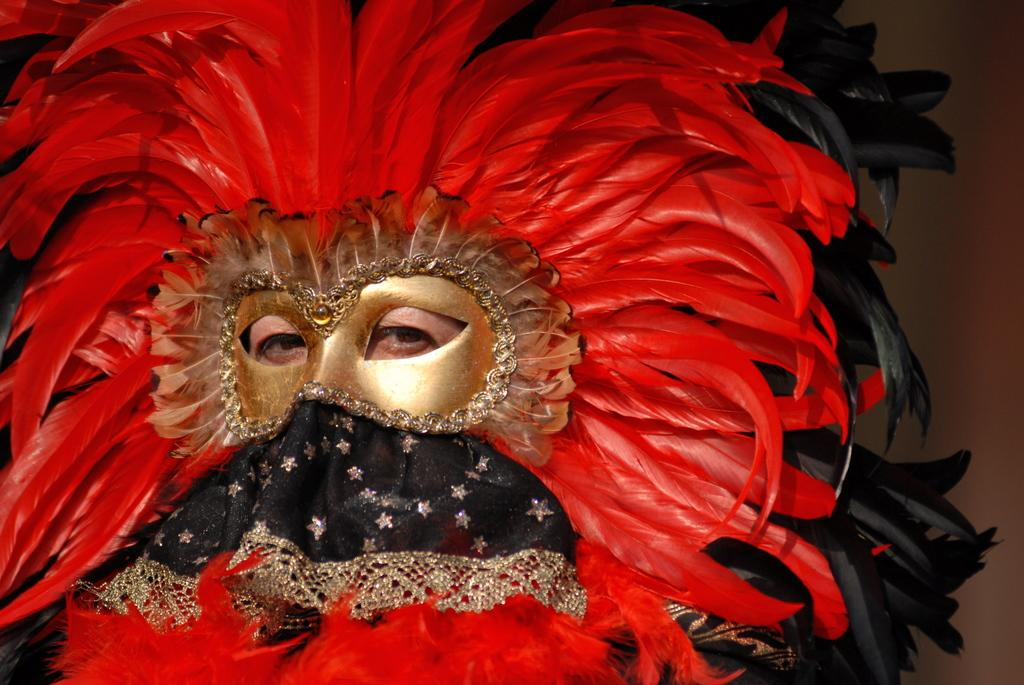What is the main subject of the image? There is a person in the image. Can you describe the person's appearance? The person is wearing a mask. What is the mask made of? The mask is made up of red and black feathers. What type of vacation is the person planning based on the image? There is no information about a vacation in the image, as it only shows a person wearing a mask made of red and black feathers. 